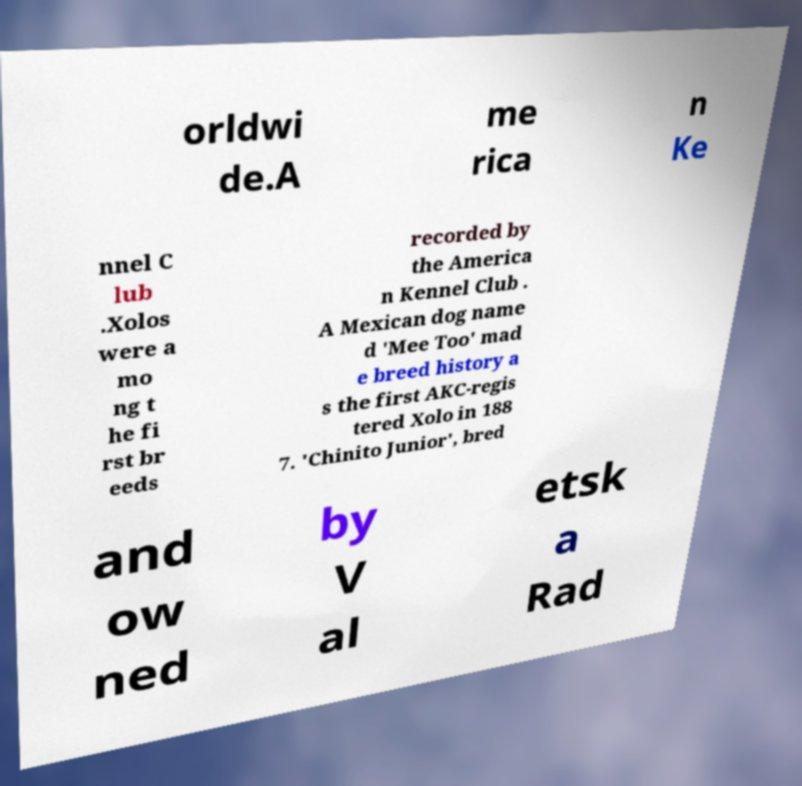For documentation purposes, I need the text within this image transcribed. Could you provide that? orldwi de.A me rica n Ke nnel C lub .Xolos were a mo ng t he fi rst br eeds recorded by the America n Kennel Club . A Mexican dog name d 'Mee Too' mad e breed history a s the first AKC-regis tered Xolo in 188 7. 'Chinito Junior', bred and ow ned by V al etsk a Rad 